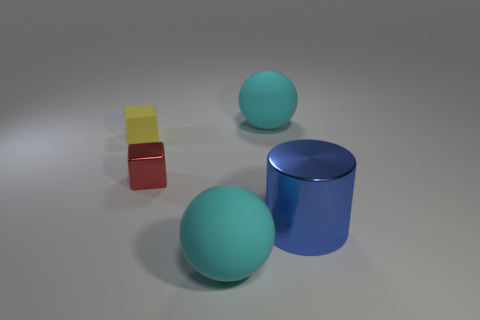What number of blue shiny cylinders are on the right side of the large cyan object left of the large sphere that is behind the small shiny block?
Provide a short and direct response. 1. How big is the matte sphere to the left of the rubber sphere behind the shiny block?
Ensure brevity in your answer.  Large. What is the size of the object that is the same material as the red block?
Keep it short and to the point. Large. There is a matte thing that is both behind the large cylinder and on the right side of the tiny rubber object; what is its shape?
Give a very brief answer. Sphere. Are there an equal number of things that are on the right side of the red thing and rubber things?
Give a very brief answer. Yes. What number of objects are large cyan objects or big spheres that are in front of the small matte cube?
Give a very brief answer. 2. Are there any large rubber objects of the same shape as the large metal object?
Keep it short and to the point. No. Are there the same number of cubes behind the small red object and small rubber objects that are in front of the tiny yellow cube?
Your answer should be compact. No. What number of green objects are matte things or rubber cubes?
Provide a short and direct response. 0. How many other blocks have the same size as the yellow matte block?
Your answer should be very brief. 1. 